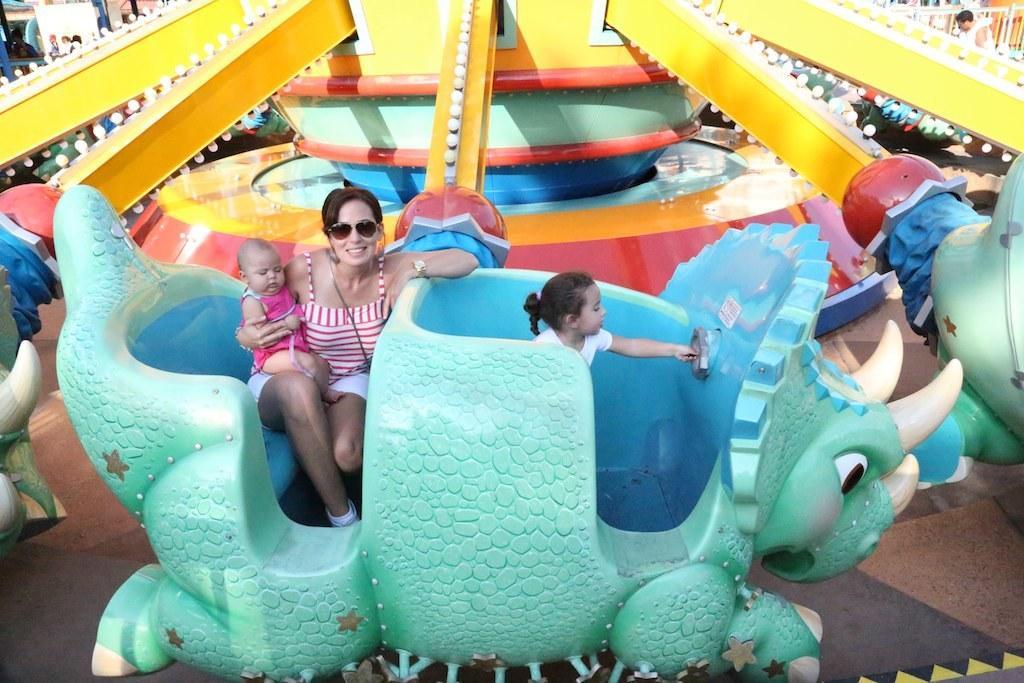Can you describe this image briefly? On the left side, there is a woman in pink color t-shirt, holding a baby, keeping this baby on her lap, keeping other hand on the statue, smiling and sitting. On the right side, there is a baby in white color t-shirt. In the background, there are persons and other objects. 